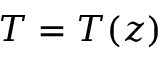<formula> <loc_0><loc_0><loc_500><loc_500>T = T ( z )</formula> 